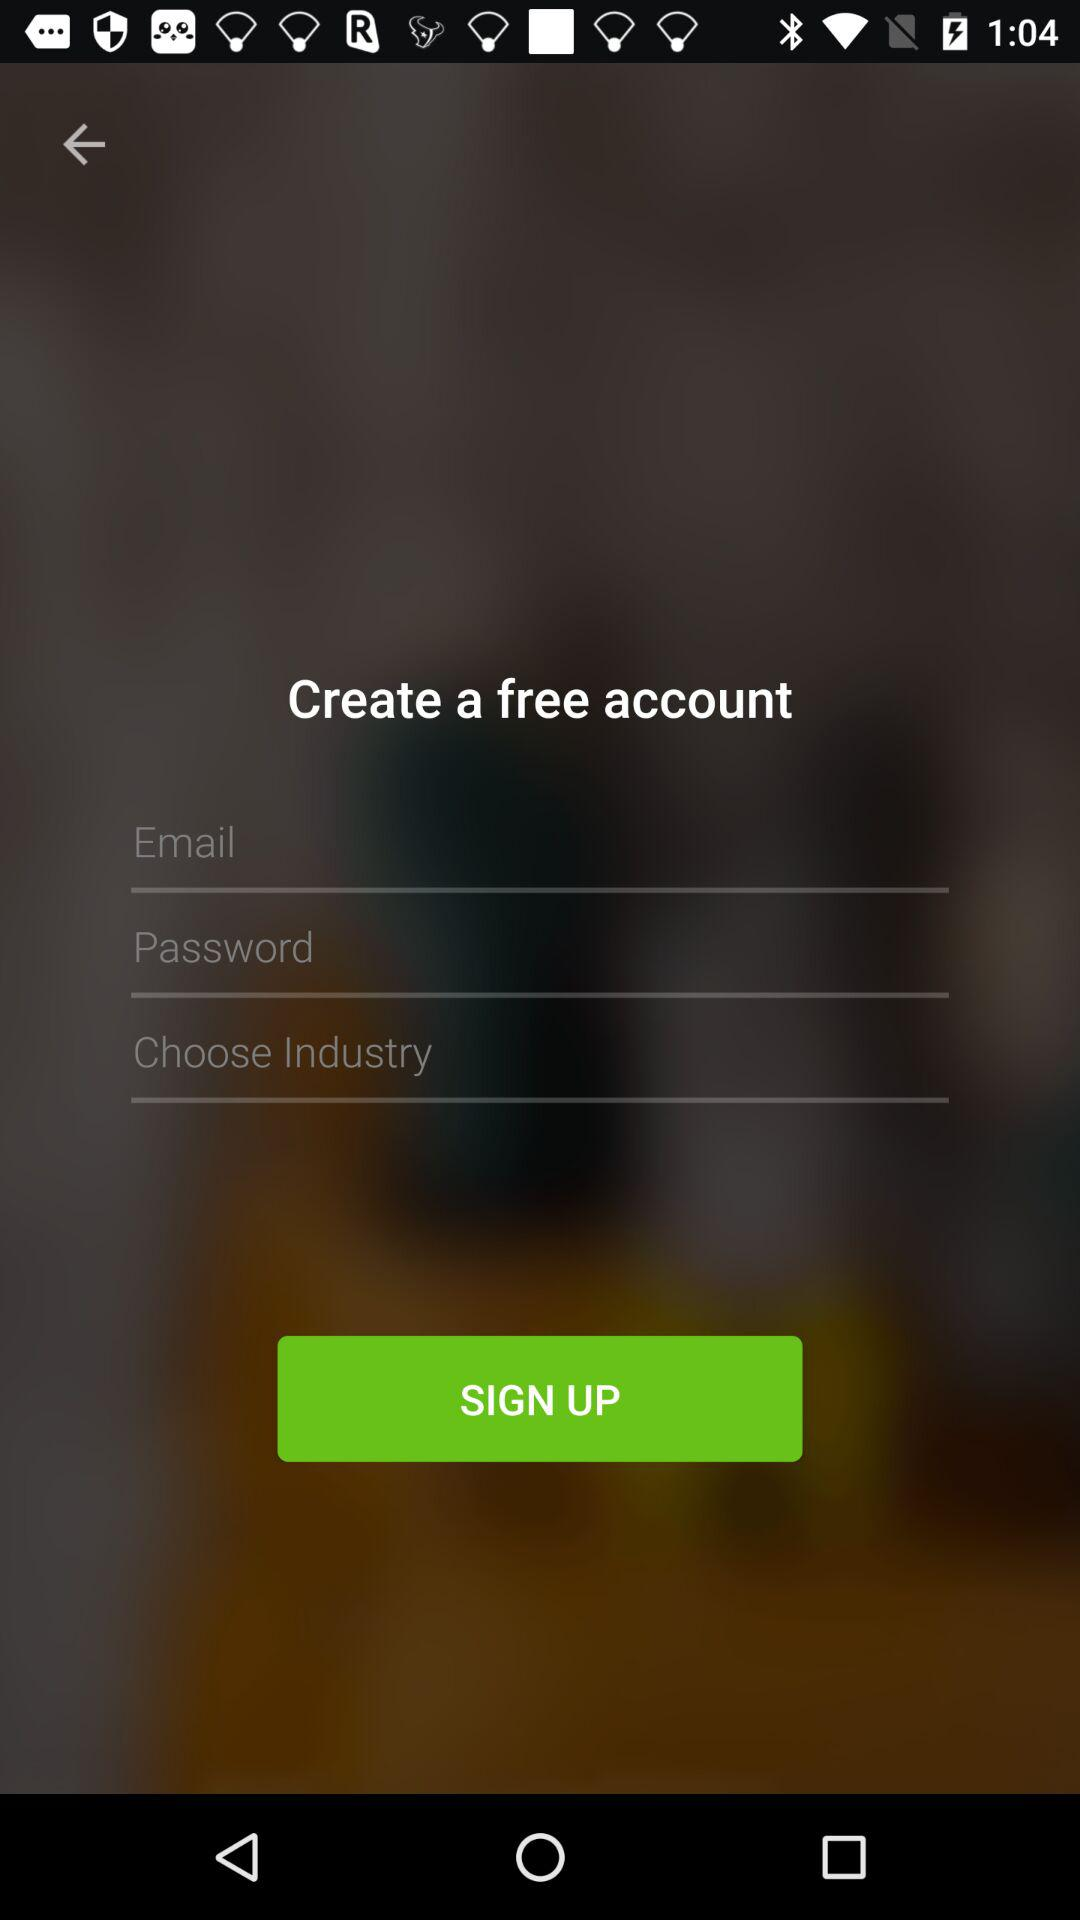How many text inputs are on the screen?
Answer the question using a single word or phrase. 3 